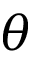<formula> <loc_0><loc_0><loc_500><loc_500>\theta</formula> 